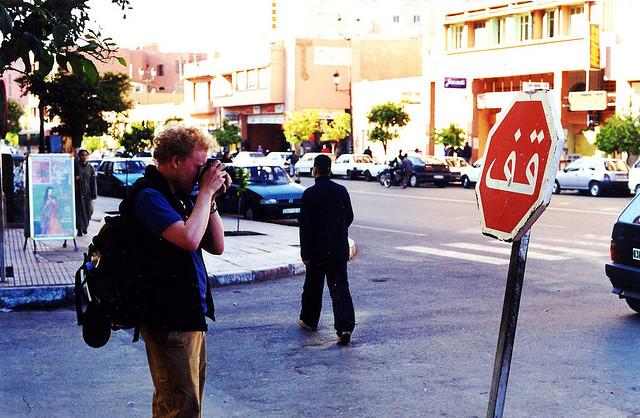Is this guy ready to swim?
Write a very short answer. No. What does the red sign say?
Be succinct. Stop. What does the red sign say?
Keep it brief. Stop. What is the man in the blue shirt doing?
Answer briefly. Taking picture. 